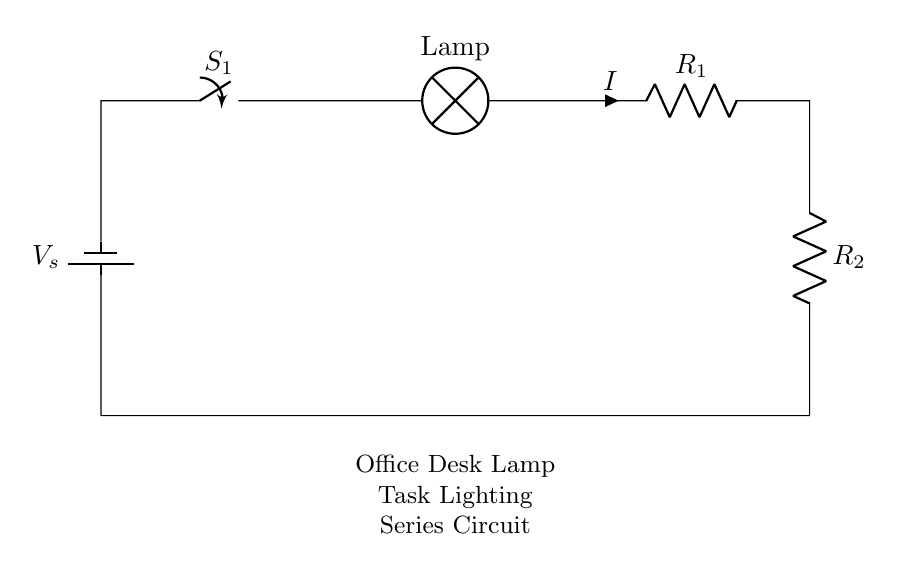What is the supply voltage in the circuit? The supply voltage is indicated next to the battery in the circuit diagram. In this case, it is denoted as V_s.
Answer: V_s What components are in this circuit? The circuit diagram shows a battery, a switch, a lamp, and two resistors. These are the basic components used in this series circuit.
Answer: Battery, switch, lamp, resistors What is the total resistance of the circuit? The total resistance in a series circuit is the sum of the individual resistances. Thus, total resistance R_total = R_1 + R_2.
Answer: R_1 + R_2 How is the current flowing through the circuit? In a series circuit, the same current flows through all components. This is a key characteristic of series connections where no branching occurs.
Answer: Same current What happens to the circuit if the switch is opened? When the switch is opened, it breaks the circuit, stopping the flow of current. Consequently, all components, including the lamp, will not function.
Answer: Current stops Which component would you find in a series circuit that might not appear in a parallel circuit? A series circuit has a combined resistance effect, which is a unique characteristic that differentiates it from parallel circuits where components are arranged side by side.
Answer: Resistor combination 